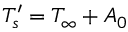Convert formula to latex. <formula><loc_0><loc_0><loc_500><loc_500>{ T _ { s } ^ { \prime } } = T _ { \infty } + A _ { 0 }</formula> 